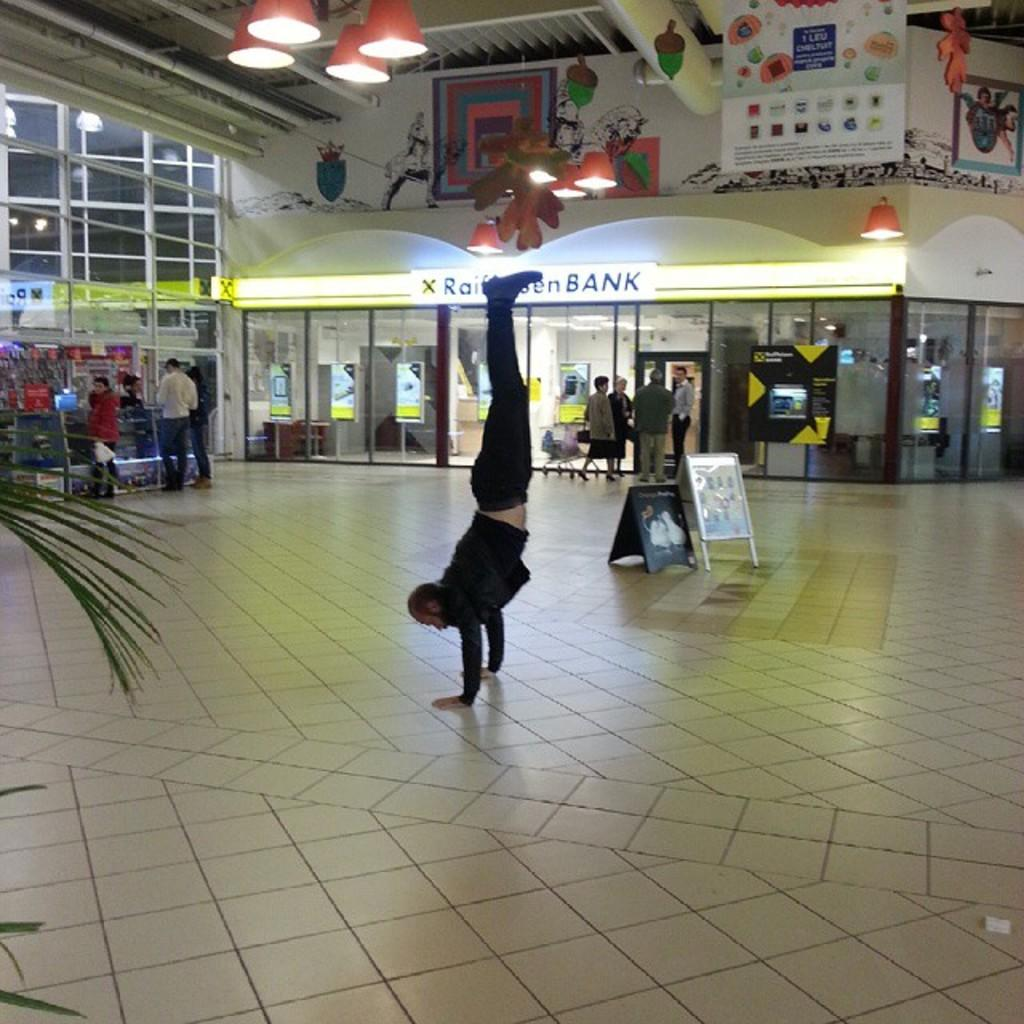What is the position of the person in the image? There is a person on the floor in the image. What can be seen in the background of the image? There is a group of people, boards, posters, lights, and some objects in the background of the image. Can you describe the group of people in the background? The group of people is visible in the background, but their specific actions or interactions cannot be determined from the image. What type of bun is the cat eating in the image? There is no cat or bun present in the image. How much milk is the person on the floor drinking in the image? There is no milk visible in the image, and the person's actions or activities cannot be determined from the image. 